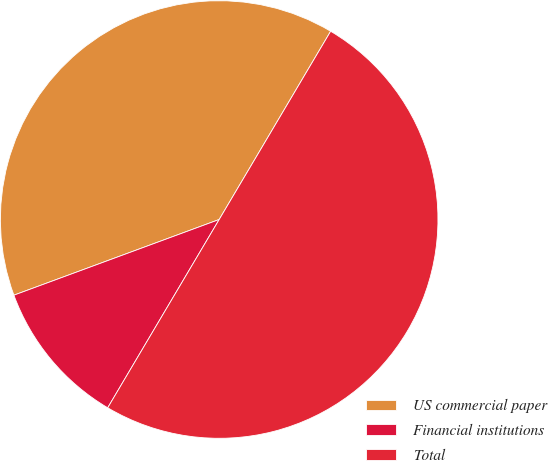Convert chart to OTSL. <chart><loc_0><loc_0><loc_500><loc_500><pie_chart><fcel>US commercial paper<fcel>Financial institutions<fcel>Total<nl><fcel>39.13%<fcel>10.87%<fcel>50.0%<nl></chart> 